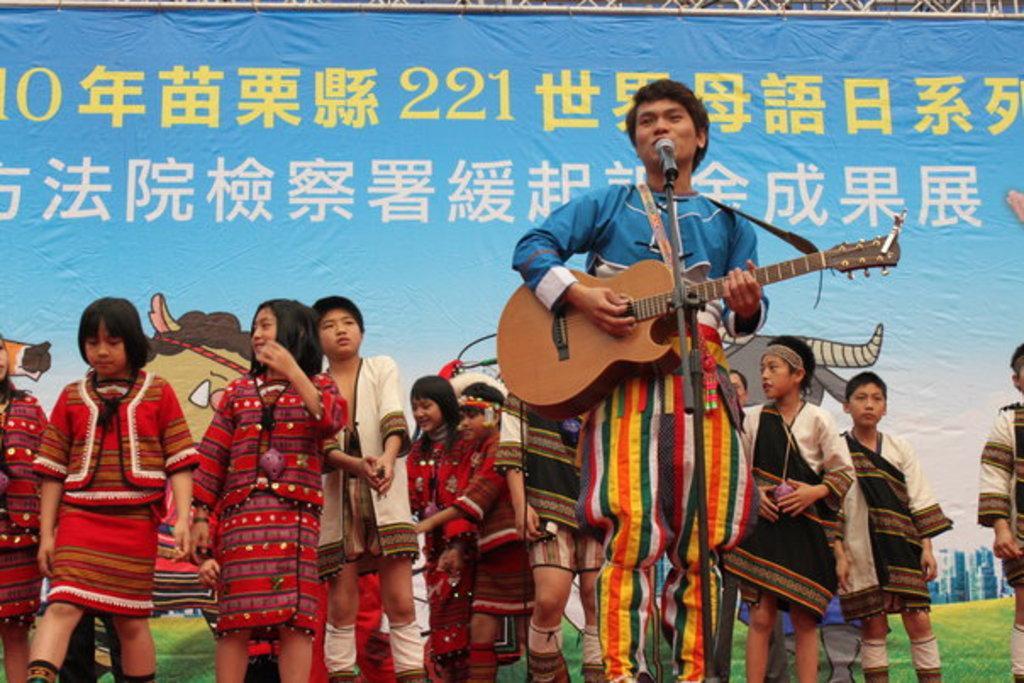How would you summarize this image in a sentence or two? In this picture we can see man standing singing on mic playing guitar with his hand and in background we can see girls and boys wore different costumes and in background we can see banner. 